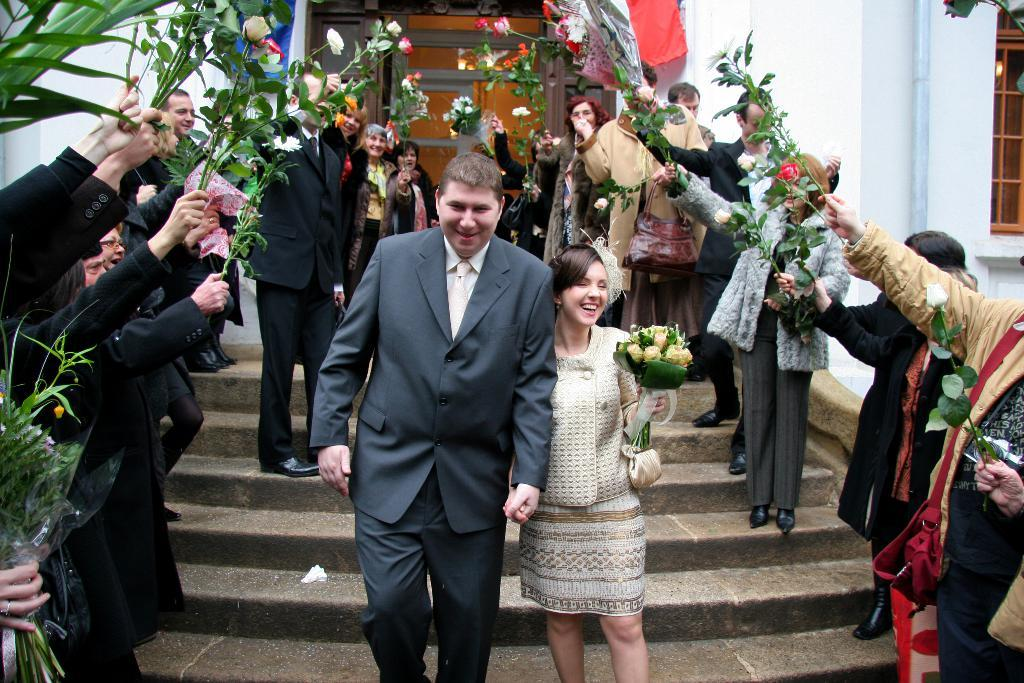What are the people in the image doing? The people in the image are standing in the middle of the image. What are the people holding in the image? The people are holding plants in the image. What can be seen in the background of the image? There is a building in the background of the image. How many sisters are present in the image? There is no mention of a sister in the image, so it cannot be determined if any are present. 